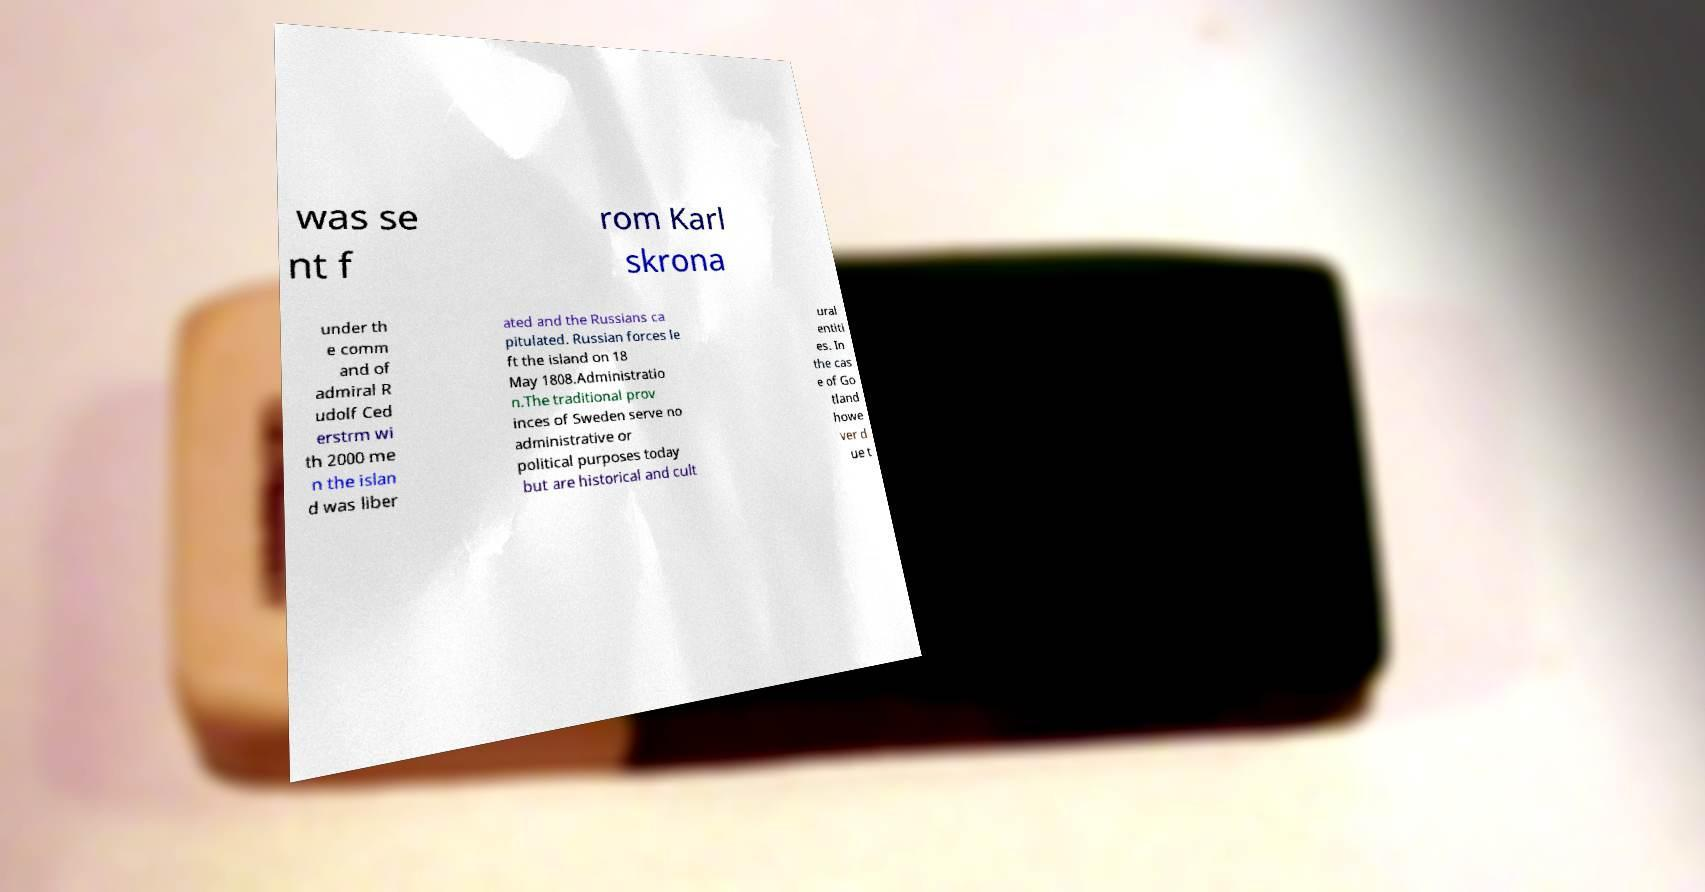Could you extract and type out the text from this image? was se nt f rom Karl skrona under th e comm and of admiral R udolf Ced erstrm wi th 2000 me n the islan d was liber ated and the Russians ca pitulated. Russian forces le ft the island on 18 May 1808.Administratio n.The traditional prov inces of Sweden serve no administrative or political purposes today but are historical and cult ural entiti es. In the cas e of Go tland howe ver d ue t 